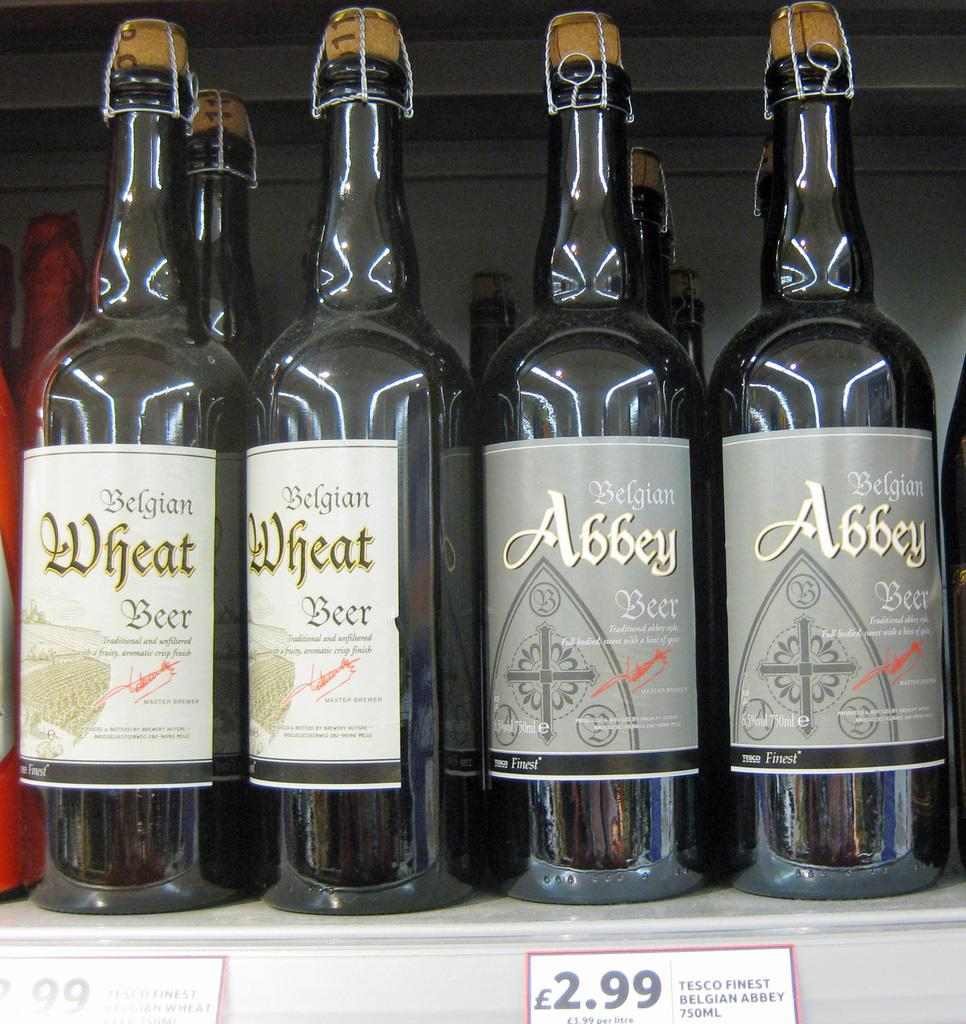<image>
Describe the image concisely. Bottles of Belgian wheat beer on a shelf next to Belgian Abbey beer. 